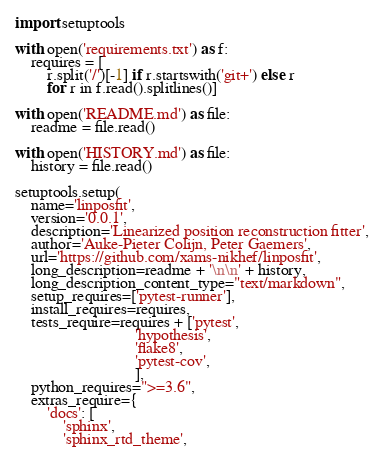Convert code to text. <code><loc_0><loc_0><loc_500><loc_500><_Python_>import setuptools

with open('requirements.txt') as f:
    requires = [
        r.split('/')[-1] if r.startswith('git+') else r
        for r in f.read().splitlines()]

with open('README.md') as file:
    readme = file.read()

with open('HISTORY.md') as file:
    history = file.read()

setuptools.setup(
    name='linposfit',
    version='0.0.1',
    description='Linearized position reconstruction fitter',
    author='Auke-Pieter Colijn, Peter Gaemers',
    url='https://github.com/xams-nikhef/linposfit',
    long_description=readme + '\n\n' + history,
    long_description_content_type="text/markdown",
    setup_requires=['pytest-runner'],
    install_requires=requires,
    tests_require=requires + ['pytest',
                              'hypothesis',
                              'flake8',
                              'pytest-cov',
                              ],
    python_requires=">=3.6",
    extras_require={
        'docs': [
            'sphinx',
            'sphinx_rtd_theme',</code> 